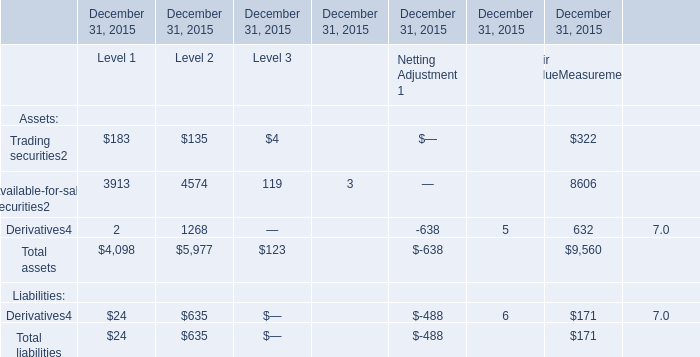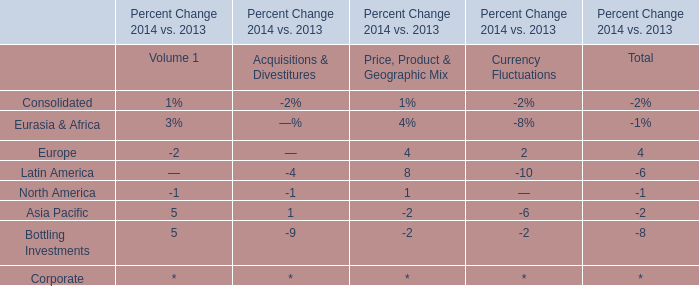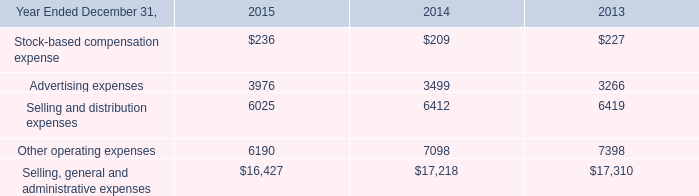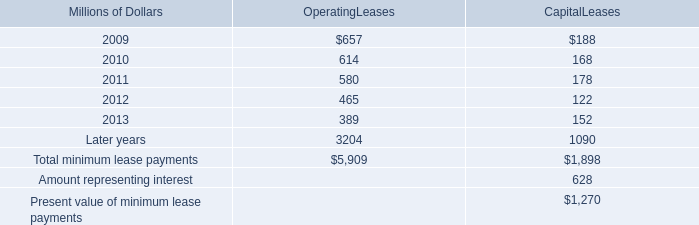How many kinds of Level 1 are greater than 100 in 2015? 
Answer: 2. 